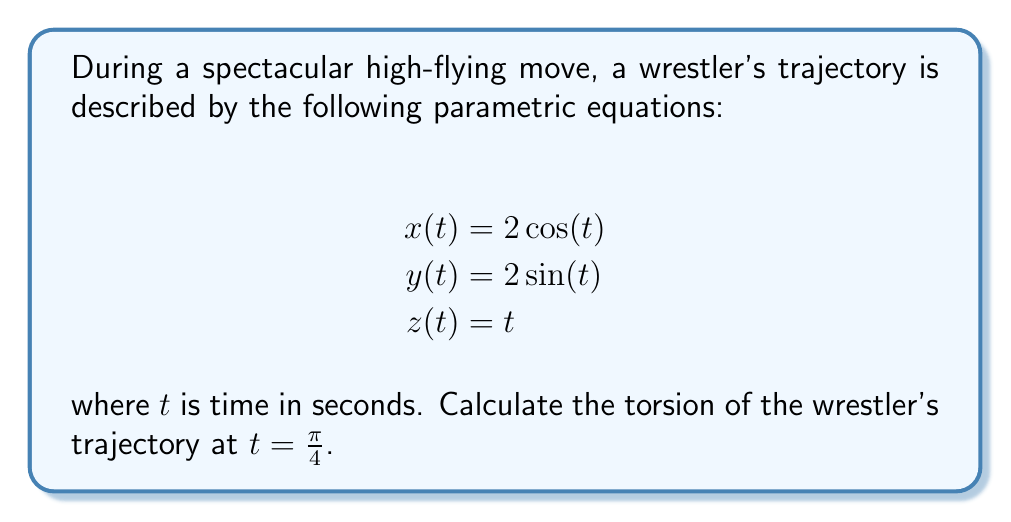What is the answer to this math problem? To calculate the torsion of the wrestler's trajectory, we'll follow these steps:

1) First, we need to calculate the first, second, and third derivatives of the position vector $\mathbf{r}(t) = (x(t), y(t), z(t))$:

   $\mathbf{r}'(t) = (-2\sin(t), 2\cos(t), 1)$
   $\mathbf{r}''(t) = (-2\cos(t), -2\sin(t), 0)$
   $\mathbf{r}'''(t) = (2\sin(t), -2\cos(t), 0)$

2) The torsion $\tau$ is given by the formula:

   $$\tau = \frac{(\mathbf{r}' \times \mathbf{r}'') \cdot \mathbf{r}'''}{|\mathbf{r}' \times \mathbf{r}''|^2}$$

3) Let's calculate $\mathbf{r}' \times \mathbf{r}''$:

   $\mathbf{r}' \times \mathbf{r}'' = (2, 2\sin(t), 2\cos(t))$

4) Now, $(\mathbf{r}' \times \mathbf{r}'') \cdot \mathbf{r}'''$:

   $(\mathbf{r}' \times \mathbf{r}'') \cdot \mathbf{r}''' = 2(2\sin(t)) + 2\sin(t)(-2\cos(t)) + 2\cos(t)(2\sin(t)) = 4$

5) Calculate $|\mathbf{r}' \times \mathbf{r}''|^2$:

   $|\mathbf{r}' \times \mathbf{r}''|^2 = 4 + 4\sin^2(t) + 4\cos^2(t) = 8$

6) Therefore, the torsion is:

   $$\tau = \frac{4}{8} = \frac{1}{2}$$

7) This result is constant and independent of $t$, so it's the same at $t = \frac{\pi}{4}$.
Answer: $\frac{1}{2}$ 